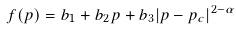<formula> <loc_0><loc_0><loc_500><loc_500>f ( p ) = b _ { 1 } + b _ { 2 } p + b _ { 3 } | p - p _ { c } | ^ { 2 - \alpha }</formula> 